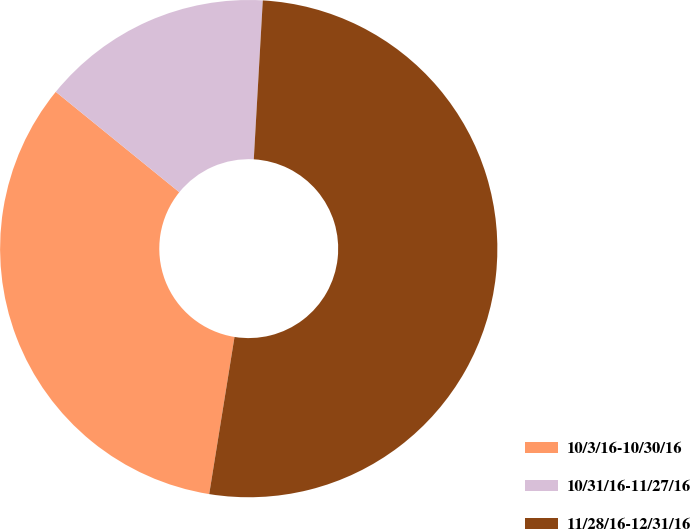Convert chart. <chart><loc_0><loc_0><loc_500><loc_500><pie_chart><fcel>10/3/16-10/30/16<fcel>10/31/16-11/27/16<fcel>11/28/16-12/31/16<nl><fcel>33.32%<fcel>15.04%<fcel>51.64%<nl></chart> 